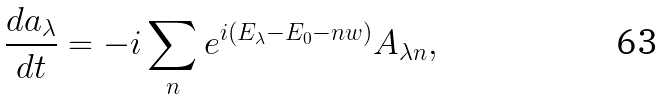Convert formula to latex. <formula><loc_0><loc_0><loc_500><loc_500>\frac { d a _ { \lambda } } { d t } = - i \sum _ { n } e ^ { i ( E _ { \lambda } - E _ { 0 } - n w ) } A _ { \lambda n } ,</formula> 